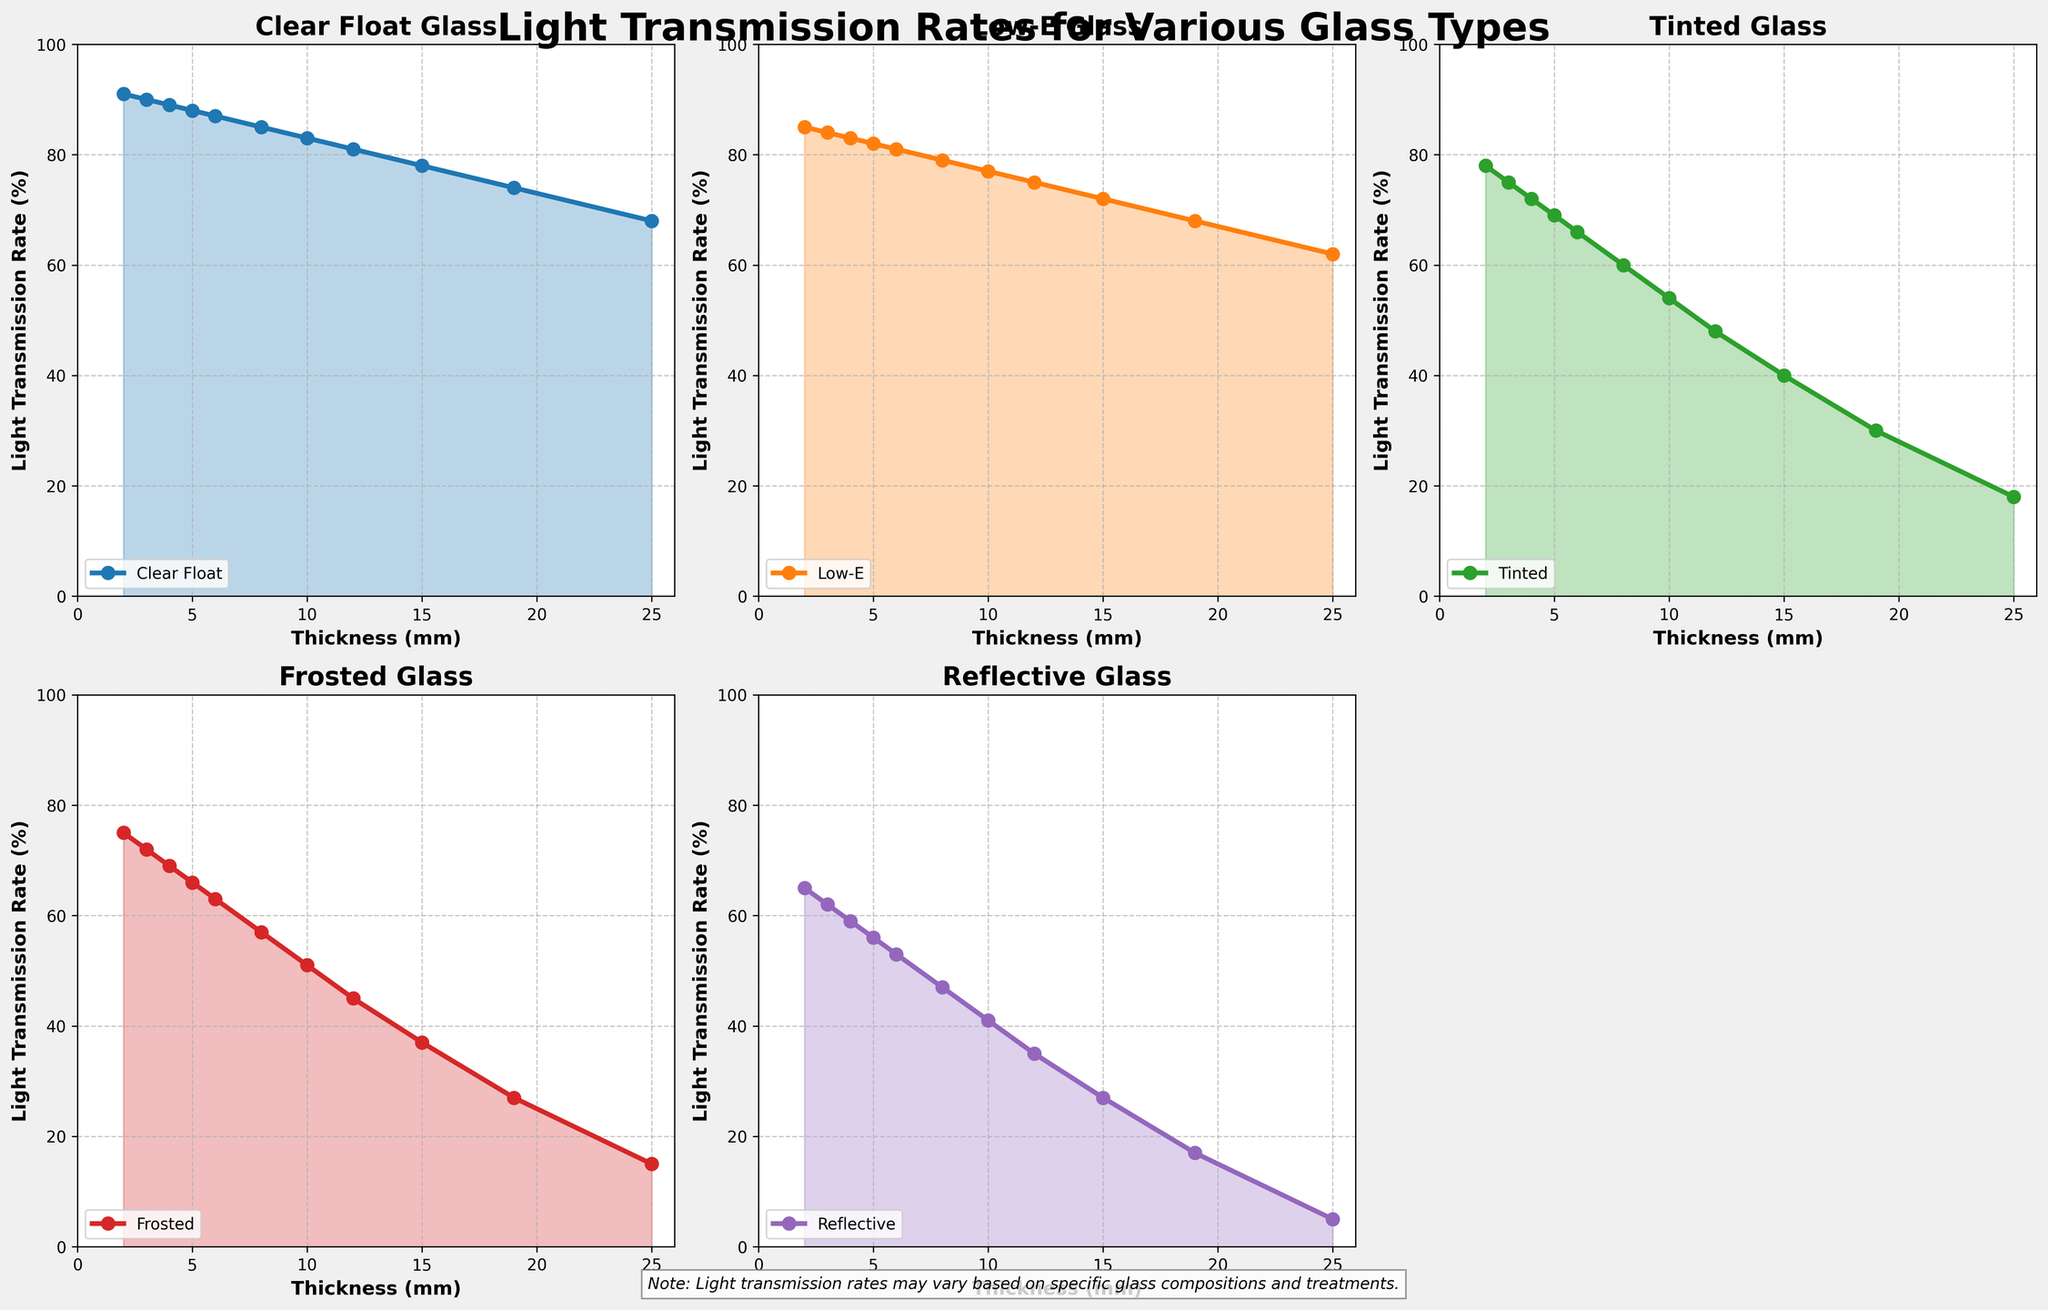What glass type has the highest light transmission rate at 10mm thickness? Locate the 10mm thickness on the x-axis. Check the y-values for each glass type at this thickness. Clear Float has the highest y-value.
Answer: Clear Float Which glass type shows the steepest decline in light transmission rate as thickness increases? Compare the slopes of the lines for each glass type. Reflective glass has the steapest decline.
Answer: Reflective What is the light transmission difference between Low-E glass at 4mm and 8mm thickness? Find the values for Low-E glass at 4mm and 8mm thickness. Subtract the light transmission rate at 8mm from the rate at 4mm (83 - 79).
Answer: 4% Which glass type has the least variation in light transmission rates across different thicknesses? Compare the range of y-values (max-min) for each glass type. Clear Float has the smallest range.
Answer: Clear Float At what thickness does Tinted glass fall below 50% light transmission rate? Identify the x-axis value where the y-value for Tinted glass drops below 50%. This occurs between 10mm and 12mm thickness, thus the first point below 50% is 12mm.
Answer: 12mm Which glass types have light transmission rates below 20% at 25mm thickness? Check the y-values for each glass type at 25mm thickness and identify those below 20%. Tinted, Frosted, and Reflective glass types all fall below 20%.
Answer: Tinted, Frosted, Reflective Compare the light transmission rates of Low-E glass and Frosted glass at 6mm thickness. Which is higher and by how much? Locate the 6mm thickness and note the y-values for both Low-E and Frosted glass. Subtract Frosted's value from Low-E's value (81 - 63).
Answer: Low-E, 18% What is the average light transmission rate for Clear Float glass over all listed thicknesses? Sum the light transmission rates of Clear Float glass across all given thicknesses and divide by the number of entries (91+90+89+88+87+85+83+81+78+74+68)/11.
Answer: 83.36% Does Frosted glass ever have a higher transmission rate than Tinted glass? If yes, at what thickness? Compare the y-values of Frosted and Tinted glass across all thicknesses. Frosted glass is never higher than Tinted glass.
Answer: No Which glass type retains above 50% light transmission rate up to the highest thickness? Check which glass types stay above 50% as the thickness increases to the highest given value. Clear Float and Low-E glass types remain above 50% until the thickest point.
Answer: Clear Float, Low-E 